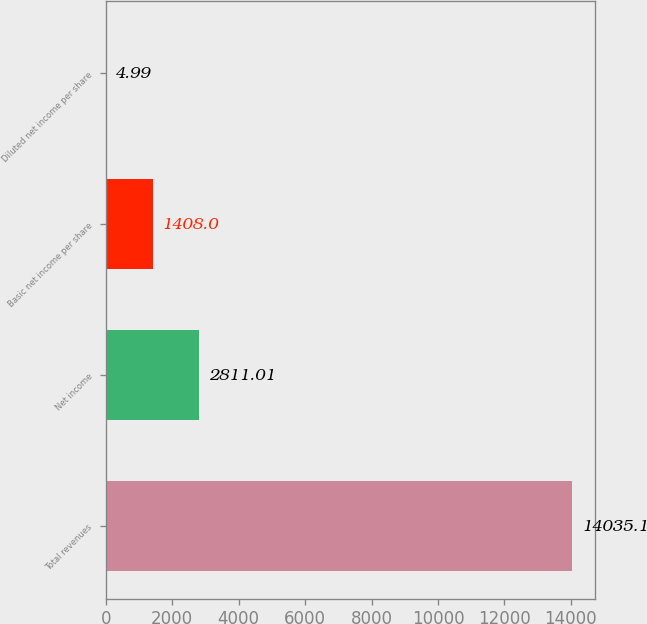<chart> <loc_0><loc_0><loc_500><loc_500><bar_chart><fcel>Total revenues<fcel>Net income<fcel>Basic net income per share<fcel>Diluted net income per share<nl><fcel>14035.1<fcel>2811.01<fcel>1408<fcel>4.99<nl></chart> 